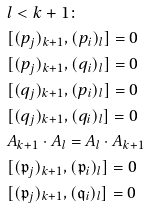<formula> <loc_0><loc_0><loc_500><loc_500>& l < k + 1 \colon \\ & [ ( { p } _ { j } ) _ { k + 1 } , ( { p } _ { i } ) _ { l } ] = 0 \\ & [ ( { p } _ { j } ) _ { k + 1 } , ( { q } _ { i } ) _ { l } ] = 0 \\ & [ ( { q } _ { j } ) _ { k + 1 } , ( { p } _ { i } ) _ { l } ] = 0 \\ & [ ( { q } _ { j } ) _ { k + 1 } , ( { q } _ { i } ) _ { l } ] = 0 \\ & A _ { k + 1 } \cdot A _ { l } = A _ { l } \cdot A _ { k + 1 } \\ & [ ( { \mathfrak p } _ { j } ) _ { k + 1 } , ( { \mathfrak p } _ { i } ) _ { l } ] = 0 \\ & [ ( { \mathfrak p } _ { j } ) _ { k + 1 } , ( { \mathfrak q } _ { i } ) _ { l } ] = 0</formula> 